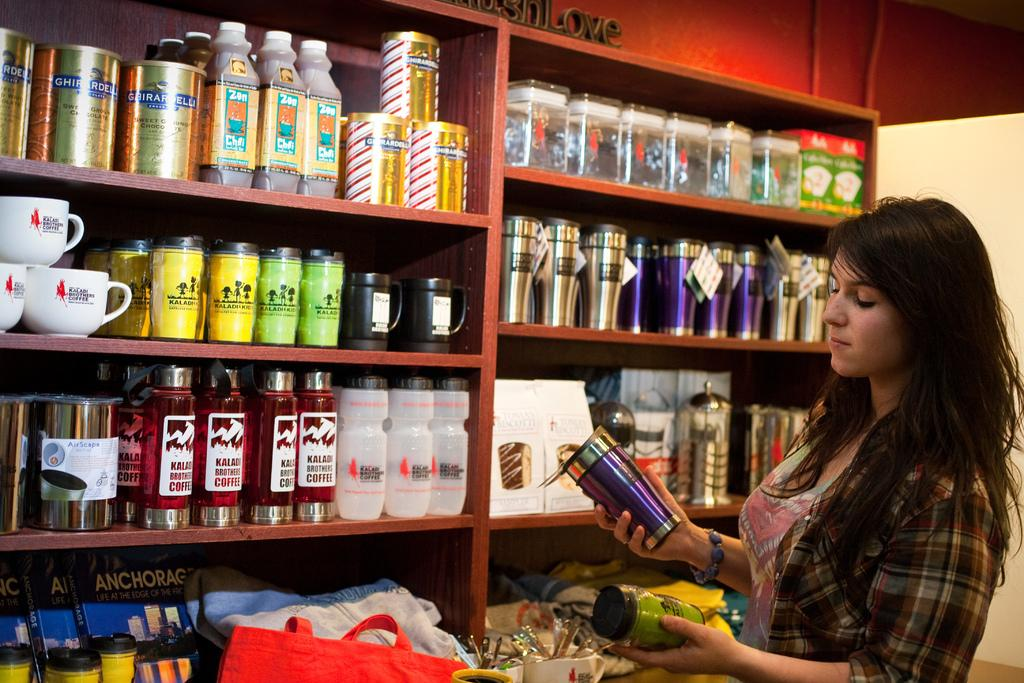Who is present in the image? There is a woman in the image. What is the woman holding in her hands? The woman is holding a can and a jar. What can be seen in the background of the image? There is a rack in the background of the image. What types of containers are on the rack? The rack contains jars, bottles, and cups. Are there any other items on the rack besides containers? Yes, there are other unspecified items on the rack. How much wealth is displayed in the image? There is no indication of wealth in the image; it features a woman holding a can and a jar, as well as a rack with various containers and unspecified items. Is there a bridge visible in the image? No, there is no bridge present in the image. 